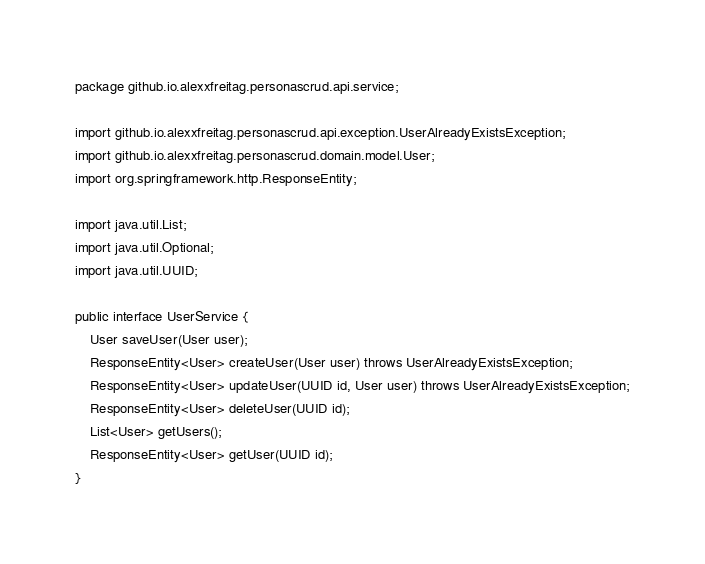<code> <loc_0><loc_0><loc_500><loc_500><_Java_>package github.io.alexxfreitag.personascrud.api.service;

import github.io.alexxfreitag.personascrud.api.exception.UserAlreadyExistsException;
import github.io.alexxfreitag.personascrud.domain.model.User;
import org.springframework.http.ResponseEntity;

import java.util.List;
import java.util.Optional;
import java.util.UUID;

public interface UserService {
    User saveUser(User user);
    ResponseEntity<User> createUser(User user) throws UserAlreadyExistsException;
    ResponseEntity<User> updateUser(UUID id, User user) throws UserAlreadyExistsException;
    ResponseEntity<User> deleteUser(UUID id);
    List<User> getUsers();
    ResponseEntity<User> getUser(UUID id);
}
</code> 